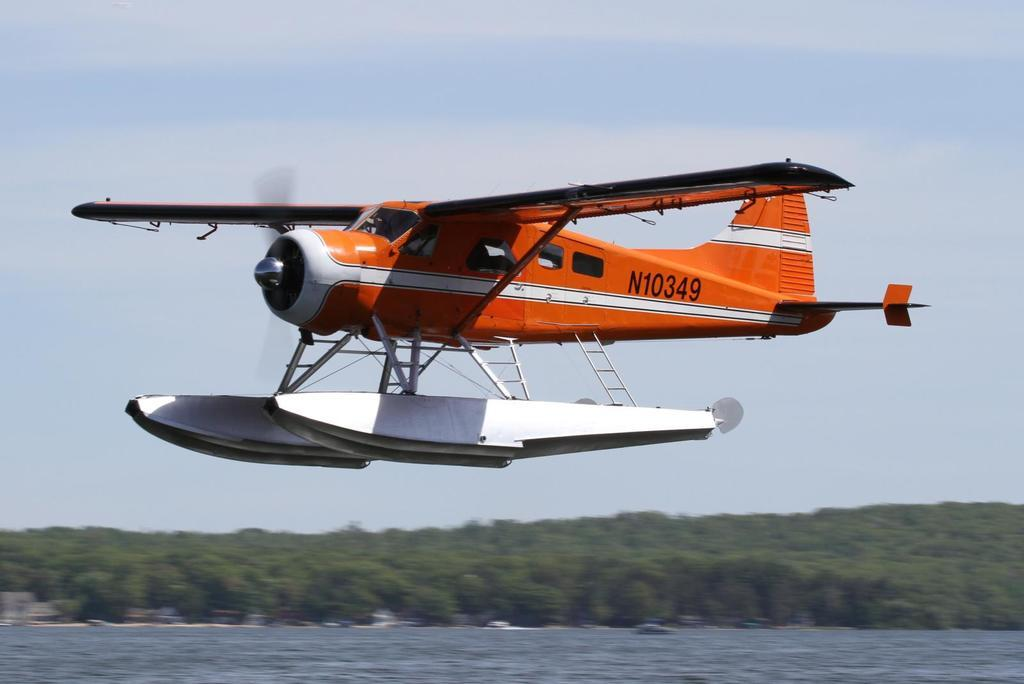<image>
Write a terse but informative summary of the picture. An orange sea plane bearing the ID n10349 flies over open water. 